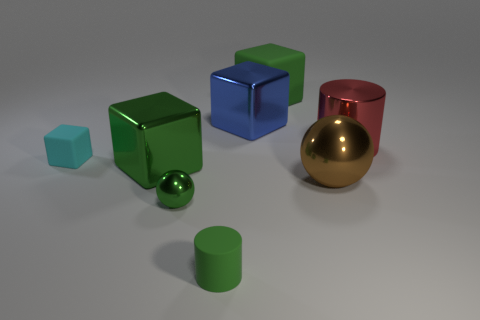Do the matte cylinder and the big rubber block have the same color?
Provide a succinct answer. Yes. There is a small sphere; is it the same color as the cylinder on the left side of the green matte block?
Your response must be concise. Yes. Are the brown ball and the cylinder in front of the big brown shiny ball made of the same material?
Offer a very short reply. No. Are there any objects of the same size as the green matte cylinder?
Give a very brief answer. Yes. Are there an equal number of green matte things that are behind the small cyan matte block and tiny green matte things?
Ensure brevity in your answer.  Yes. The blue object is what size?
Your answer should be compact. Large. How many cyan rubber blocks are to the left of the big green block in front of the small matte block?
Offer a terse response. 1. There is a green thing that is to the right of the small shiny object and in front of the big brown sphere; what is its shape?
Give a very brief answer. Cylinder. How many big metal cubes are the same color as the small shiny object?
Offer a terse response. 1. There is a metallic ball left of the green rubber object behind the large blue cube; is there a large matte cube left of it?
Ensure brevity in your answer.  No. 